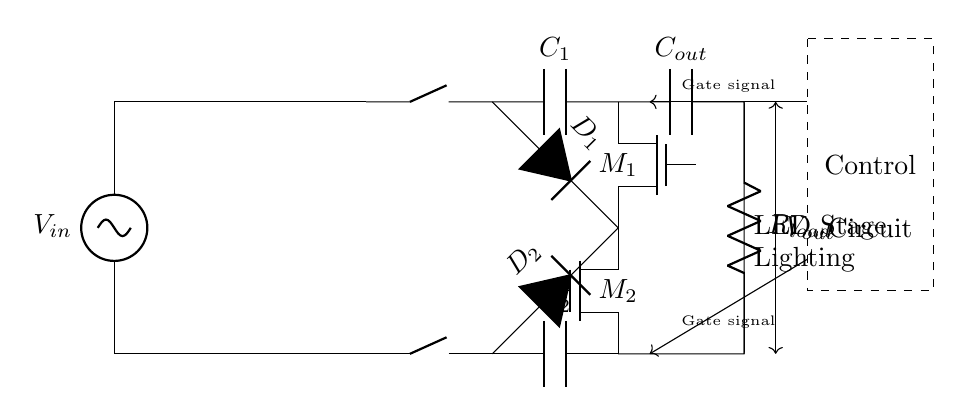what is the type of active components used in this circuit? The circuit utilizes N-channel MOSFETs, indicated by the symbols labeled M1 and M2. These are the active components that allow for synchronous rectification.
Answer: N-channel MOSFETs what is the role of the control circuit? The control circuit sends gate signals to the MOSFETs (M1 and M2), controlling their switching states. This operation is crucial for synchronously rectifying the incoming AC signal efficiently.
Answer: Control of gate signals how many capacitors are present in the circuit? There are three capacitors labeled C1, C2, and Cout. These capacitors are used for filtering and smoothing the output voltage.
Answer: Three what is the purpose of the bridge rectifier in this circuit? The bridge rectifier converts the AC input voltage from the transformer into a pulsating DC voltage, which is necessary before further rectification by the MOSFETs.
Answer: Convert AC to DC what is the load connected at the output? The load is represented by resistor Rload, which signifies the LED stage lighting system that the circuit is designed to power.
Answer: Resistor what is the function of the output capacitor Cout? Cout smooths out the pulsating DC voltage after rectification, providing a more stable output voltage for the load. This is essential for the proper operation of the LED stage lighting.
Answer: Voltage smoothing what does the dashed rectangle in the circuit represent? The dashed rectangle indicates a control circuit that includes the logic and feedback mechanisms necessary to manage the switching of the MOSFETs based on the input conditions.
Answer: Control circuit 